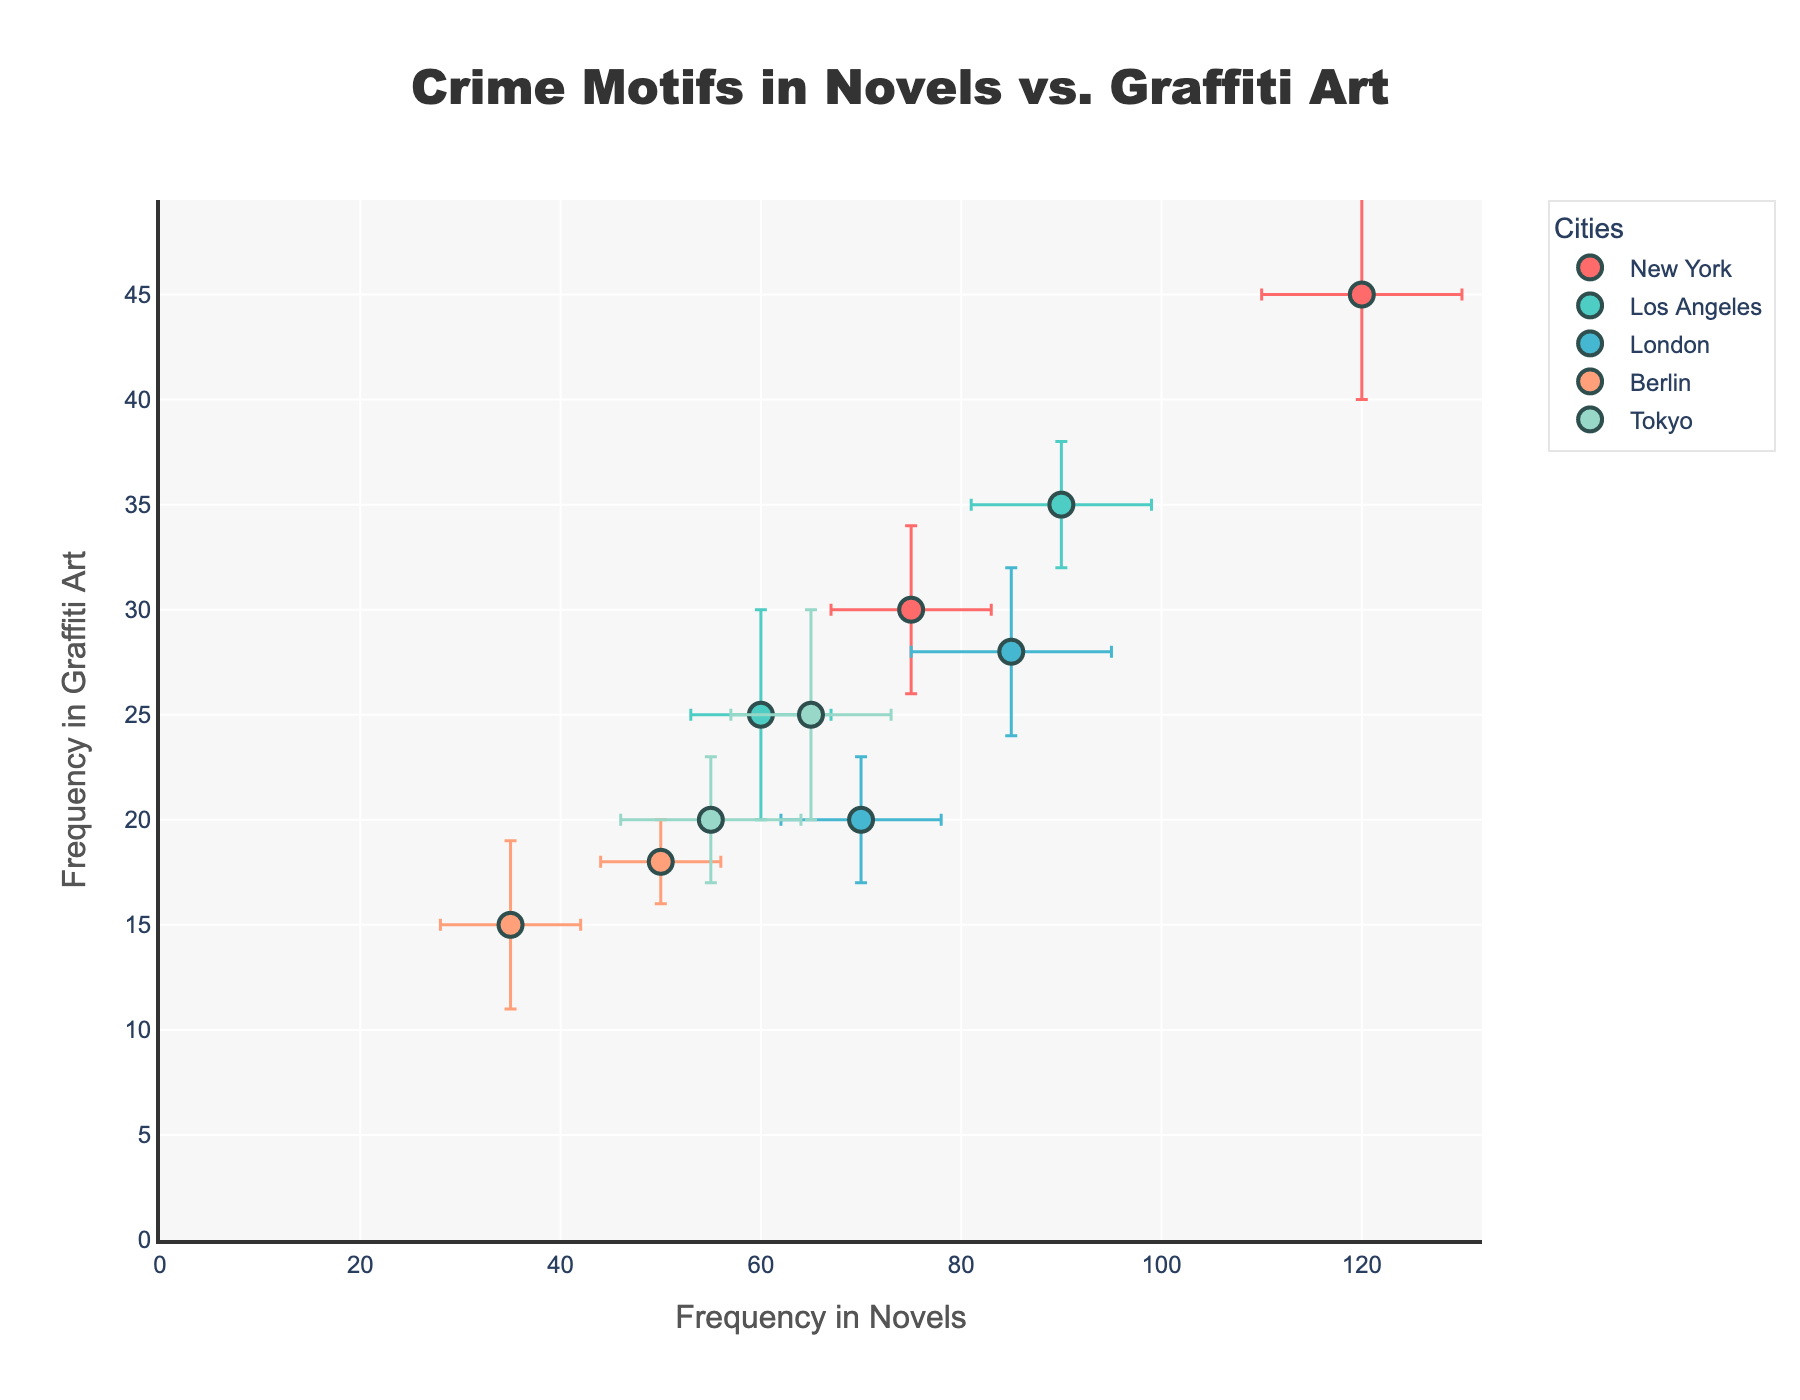What is the title of the scatter plot? The title can be found at the top of the figure, indicating the main topic of the plot.
Answer: Crime Motifs in Novels vs. Graffiti Art Which city shows the highest frequency of "Murder" motifs in novels? The x-axis represents the frequency in novels. Find the data point with "Murder" as the motif and locate which city's marker has the highest x-coordinate.
Answer: New York How does the frequency of "Heist" motifs in novels compare to graffiti in Los Angeles? Look at the coordinates of the "Heist" motif corresponding to Los Angeles. Compare the x-axis value (Novels) and the y-axis value (Graffiti).
Answer: 90 (Novels) vs. 35 (Graffiti) What is the average frequency of "Betrayal" motifs in graffiti in London? Since there is only one data point for "Betrayal" in London, the average frequency will be the same as the y-axis value of that point.
Answer: 20 Which motif identified in Berlin has more variability in graffiti frequencies? Compare the error bars' lengths in the y-axis for Berlin motifs. The one with the longer error bar has more variability in graffiti frequencies.
Answer: Kidnapping Between "Underworld" and "Revenge" motifs in Tokyo, which one appears more frequently in graffiti? For both 'Underworld' and 'Revenge' motifs in Tokyo, compare their y-axis values to determine which is higher.
Answer: Underworld How do the error bars for "Police Corruption" motif in Los Angeles help in understanding the variability in graffiti frequencies? The error bars indicate the uncertainty or variability in the collected data. Observing the length of error bars in the y-axis for "Police Corruption" will show the range of variability in graffiti frequencies.
Answer: They show a variability of 5 units What is the difference in the frequency of "Organized Crime" motifs in novels vs. graffiti in Berlin? Subtract the y-axis value (Graffiti) of "Organized Crime" in Berlin from its x-axis value (Novels).
Answer: 32 Which city and motif combination has the smallest error bar in novels? Check for the shortest error bars along the x-axis for all city and motif combinations.
Answer: Organized Crime in Berlin Does the frequency of "Serial Killers" motifs in London novels suggest higher uncertainty compared to "Rival Gangs" in New York novels? Compare the lengths of the error bars along the x-axis for "Serial Killers" in London and "Rival Gangs" in New York to determine which has greater uncertainty.
Answer: Yes 